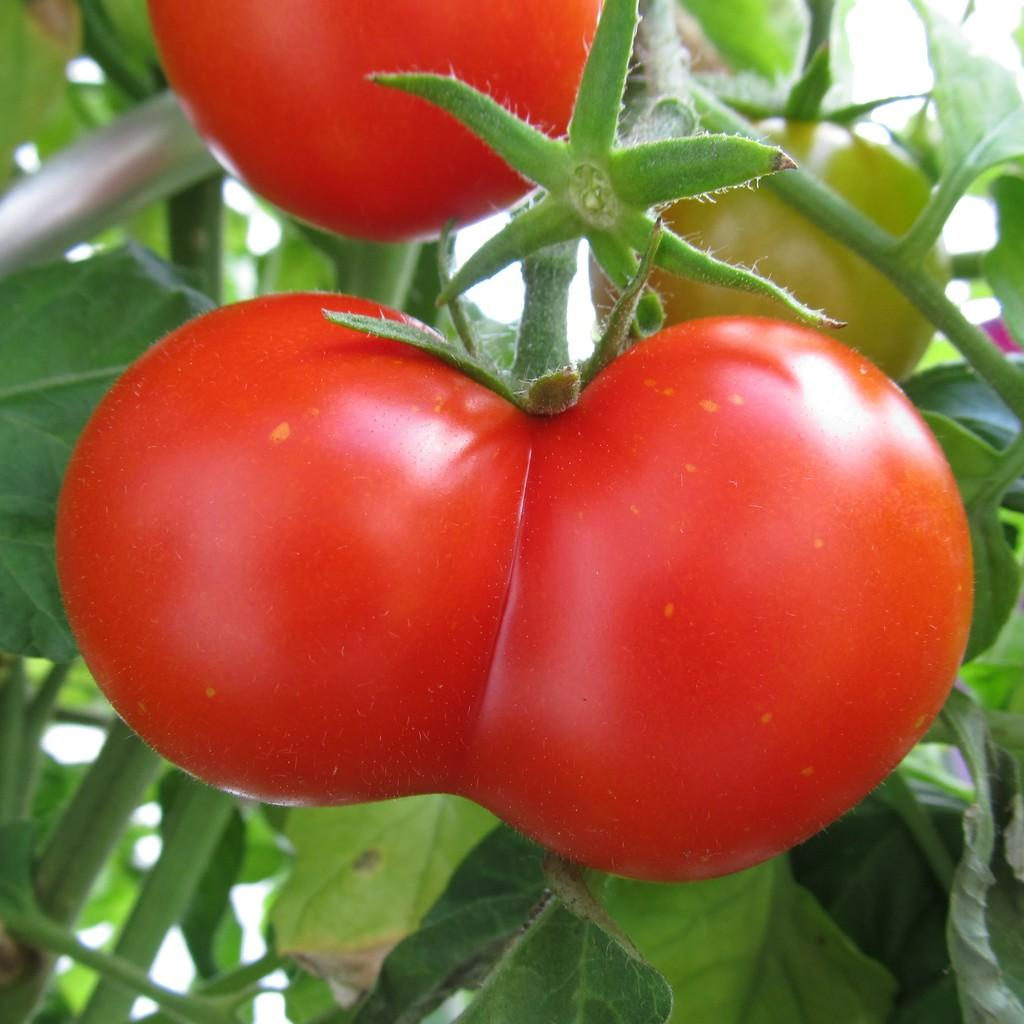What type of plant is visible in the image? There are tomatoes on a plant in the image. What is growing on the plant? Tomatoes are growing on the plant in the image. What type of property is being sold in the image? There is no property being sold in the image; it only features a tomato plant. How much payment is required to purchase the tomatoes in the image? There is no payment required to purchase the tomatoes in the image, as they are not for sale. 